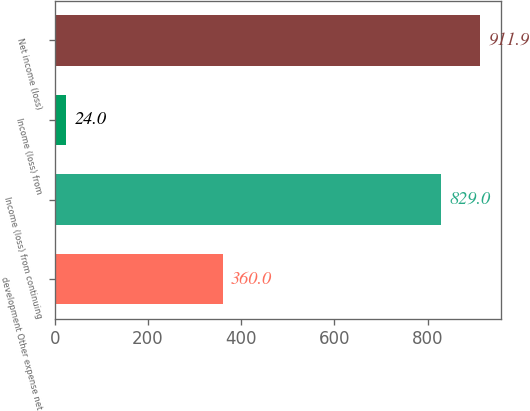<chart> <loc_0><loc_0><loc_500><loc_500><bar_chart><fcel>development Other expense net<fcel>Income (loss) from continuing<fcel>Income (loss) from<fcel>Net income (loss)<nl><fcel>360<fcel>829<fcel>24<fcel>911.9<nl></chart> 